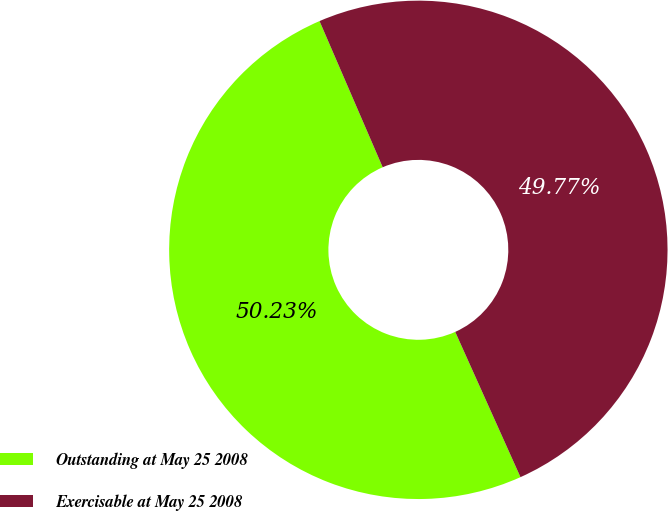Convert chart to OTSL. <chart><loc_0><loc_0><loc_500><loc_500><pie_chart><fcel>Outstanding at May 25 2008<fcel>Exercisable at May 25 2008<nl><fcel>50.23%<fcel>49.77%<nl></chart> 